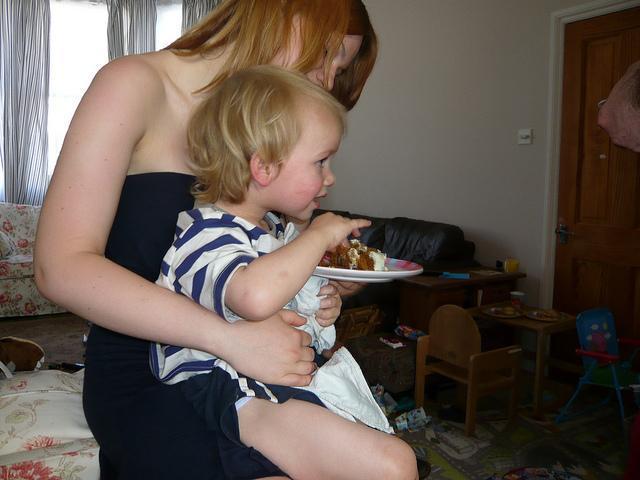How many bananas does the boy have?
Give a very brief answer. 0. How many chairs are visible?
Give a very brief answer. 2. How many people are in the picture?
Give a very brief answer. 2. How many couches can be seen?
Give a very brief answer. 2. 